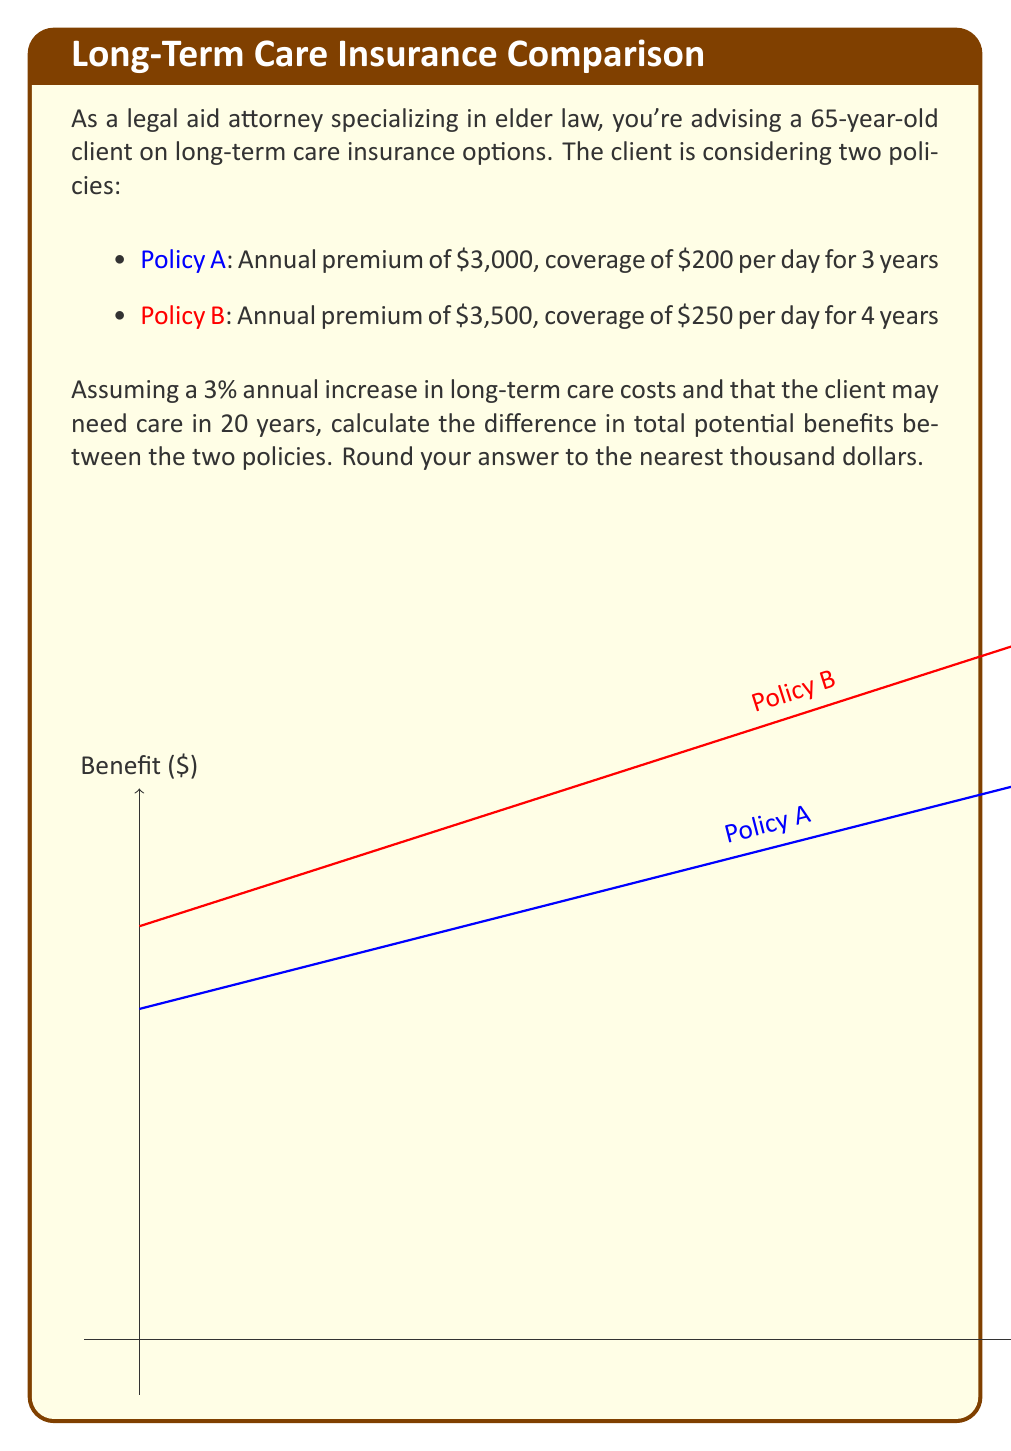What is the answer to this math problem? Let's approach this step-by-step:

1) First, we need to calculate the daily benefit amount after 20 years, considering the 3% annual increase:

   For Policy A: $200 \times (1.03)^{20} = 200 \times 1.8061 = \$361.22$ per day
   For Policy B: $250 \times (1.03)^{20} = 250 \times 1.8061 = \$451.53$ per day

2) Now, let's calculate the total benefit for each policy:

   Policy A: $\$361.22$ per day for 3 years
   $$361.22 \times 365 \times 3 = \$395,535.90$$

   Policy B: $\$451.53$ per day for 4 years
   $$451.53 \times 365 \times 4 = \$659,233.80$$

3) The difference in total potential benefits is:

   $$659,233.80 - 395,535.90 = \$263,697.90$$

4) Rounding to the nearest thousand:

   $\$263,697.90 \approx \$264,000$

Therefore, the difference in total potential benefits between Policy B and Policy A is approximately $264,000.
Answer: $264,000 